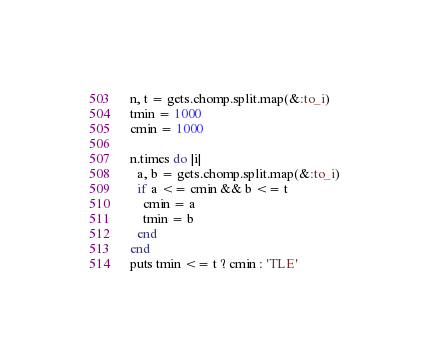Convert code to text. <code><loc_0><loc_0><loc_500><loc_500><_Ruby_>n, t = gets.chomp.split.map(&:to_i)
tmin = 1000
cmin = 1000

n.times do |i|
  a, b = gets.chomp.split.map(&:to_i)
  if a <= cmin && b <= t
    cmin = a
    tmin = b
  end
end
puts tmin <= t ? cmin : 'TLE'
</code> 